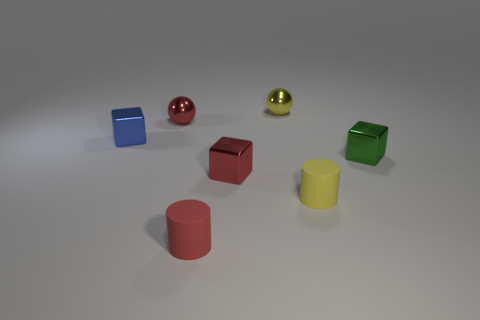Subtract all red blocks. How many blocks are left? 2 Subtract all blue cubes. How many cubes are left? 2 Subtract 1 blocks. How many blocks are left? 2 Add 3 big yellow cubes. How many objects exist? 10 Subtract all balls. How many objects are left? 5 Add 6 tiny cyan rubber things. How many tiny cyan rubber things exist? 6 Subtract 1 blue cubes. How many objects are left? 6 Subtract all brown blocks. Subtract all yellow balls. How many blocks are left? 3 Subtract all rubber objects. Subtract all tiny brown rubber blocks. How many objects are left? 5 Add 5 small yellow balls. How many small yellow balls are left? 6 